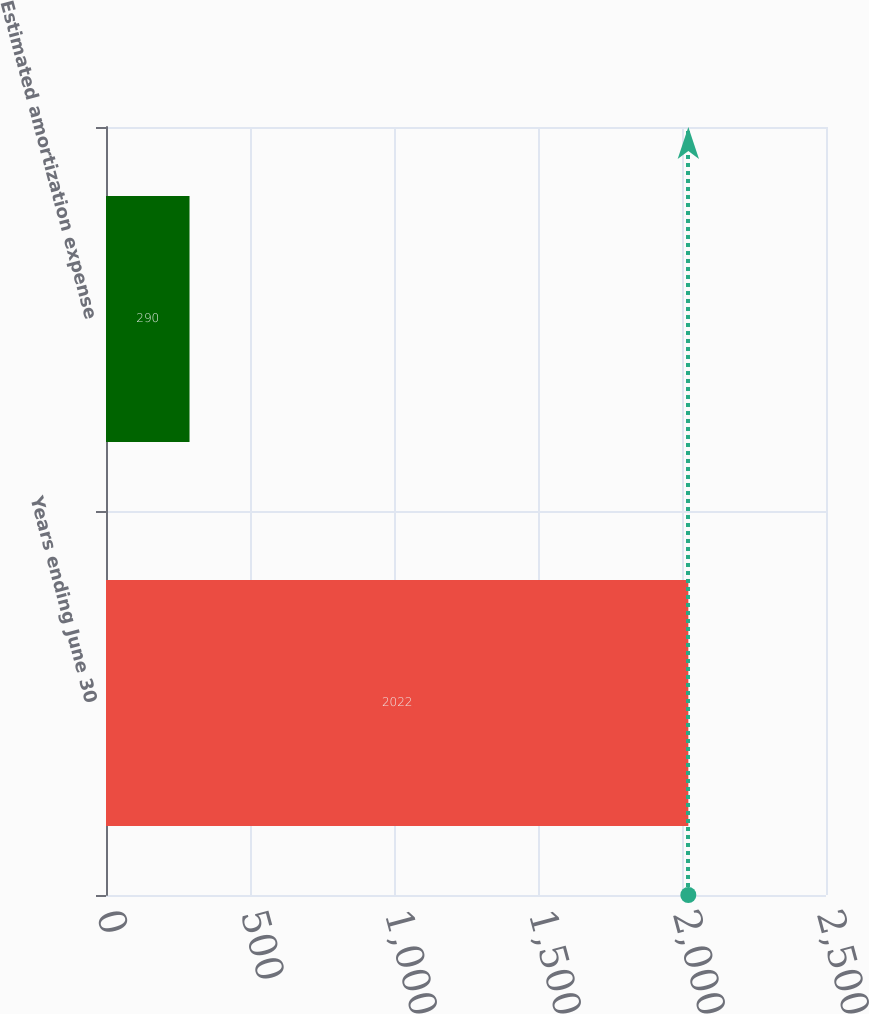Convert chart. <chart><loc_0><loc_0><loc_500><loc_500><bar_chart><fcel>Years ending June 30<fcel>Estimated amortization expense<nl><fcel>2022<fcel>290<nl></chart> 